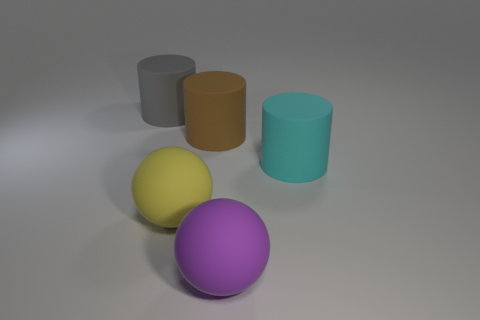What kind of surface are these objects placed on, and what does it tell you about the setting? The objects are on a flat, even surface, seemingly matte and monochromatic, which often indicates an intentional setup for a picture, such as a product photo or a 3D rendering demonstration, rather than a natural setting. 